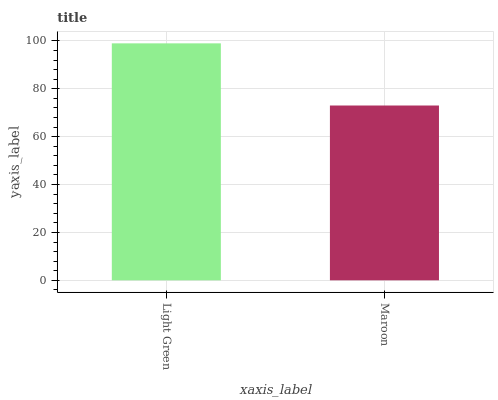Is Maroon the minimum?
Answer yes or no. Yes. Is Light Green the maximum?
Answer yes or no. Yes. Is Maroon the maximum?
Answer yes or no. No. Is Light Green greater than Maroon?
Answer yes or no. Yes. Is Maroon less than Light Green?
Answer yes or no. Yes. Is Maroon greater than Light Green?
Answer yes or no. No. Is Light Green less than Maroon?
Answer yes or no. No. Is Light Green the high median?
Answer yes or no. Yes. Is Maroon the low median?
Answer yes or no. Yes. Is Maroon the high median?
Answer yes or no. No. Is Light Green the low median?
Answer yes or no. No. 